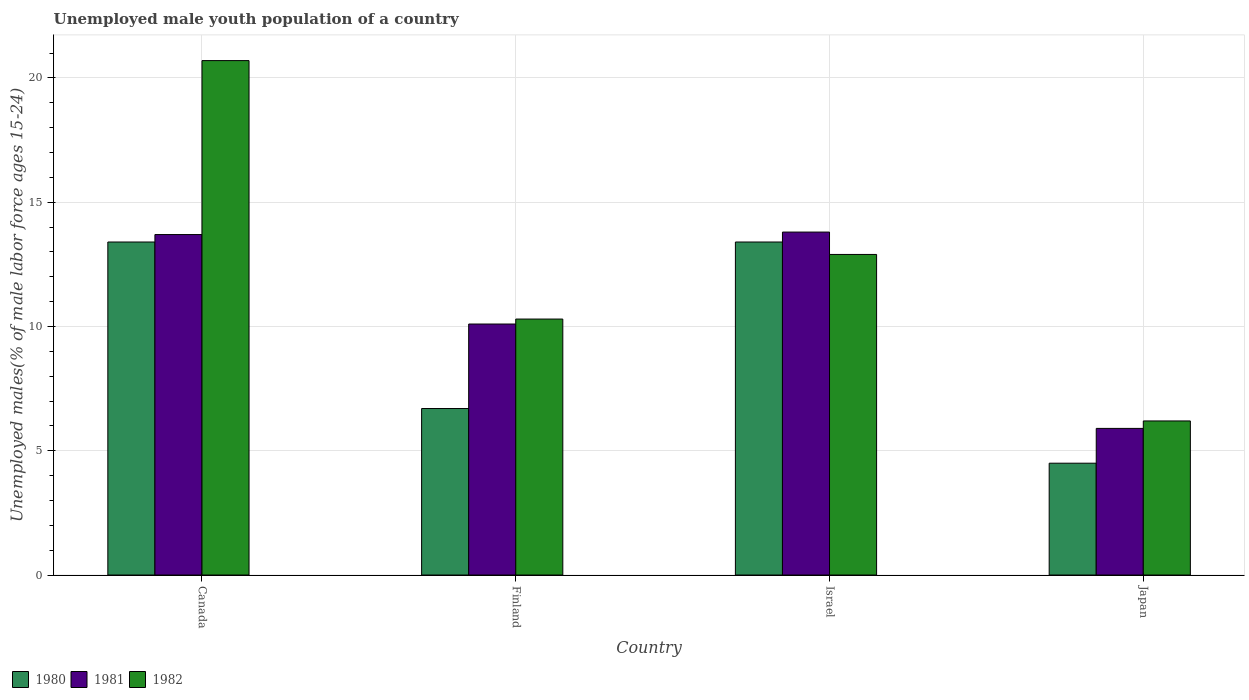How many groups of bars are there?
Provide a short and direct response. 4. Are the number of bars on each tick of the X-axis equal?
Provide a succinct answer. Yes. How many bars are there on the 2nd tick from the left?
Ensure brevity in your answer.  3. How many bars are there on the 2nd tick from the right?
Your answer should be compact. 3. What is the label of the 2nd group of bars from the left?
Provide a short and direct response. Finland. In how many cases, is the number of bars for a given country not equal to the number of legend labels?
Keep it short and to the point. 0. What is the percentage of unemployed male youth population in 1982 in Canada?
Your answer should be very brief. 20.7. Across all countries, what is the maximum percentage of unemployed male youth population in 1980?
Your response must be concise. 13.4. Across all countries, what is the minimum percentage of unemployed male youth population in 1981?
Offer a very short reply. 5.9. What is the total percentage of unemployed male youth population in 1982 in the graph?
Provide a succinct answer. 50.1. What is the difference between the percentage of unemployed male youth population in 1980 in Canada and that in Japan?
Give a very brief answer. 8.9. What is the difference between the percentage of unemployed male youth population in 1982 in Canada and the percentage of unemployed male youth population in 1980 in Japan?
Your answer should be very brief. 16.2. What is the average percentage of unemployed male youth population in 1980 per country?
Give a very brief answer. 9.5. What is the difference between the percentage of unemployed male youth population of/in 1981 and percentage of unemployed male youth population of/in 1982 in Canada?
Make the answer very short. -7. What is the ratio of the percentage of unemployed male youth population in 1981 in Finland to that in Israel?
Keep it short and to the point. 0.73. Is the difference between the percentage of unemployed male youth population in 1981 in Canada and Israel greater than the difference between the percentage of unemployed male youth population in 1982 in Canada and Israel?
Keep it short and to the point. No. What is the difference between the highest and the second highest percentage of unemployed male youth population in 1981?
Make the answer very short. 3.6. What is the difference between the highest and the lowest percentage of unemployed male youth population in 1982?
Your answer should be very brief. 14.5. In how many countries, is the percentage of unemployed male youth population in 1980 greater than the average percentage of unemployed male youth population in 1980 taken over all countries?
Your response must be concise. 2. Is the sum of the percentage of unemployed male youth population in 1982 in Canada and Finland greater than the maximum percentage of unemployed male youth population in 1980 across all countries?
Make the answer very short. Yes. What does the 1st bar from the right in Israel represents?
Provide a succinct answer. 1982. Does the graph contain grids?
Your answer should be compact. Yes. Where does the legend appear in the graph?
Your response must be concise. Bottom left. How are the legend labels stacked?
Provide a short and direct response. Horizontal. What is the title of the graph?
Provide a succinct answer. Unemployed male youth population of a country. What is the label or title of the X-axis?
Provide a short and direct response. Country. What is the label or title of the Y-axis?
Your answer should be very brief. Unemployed males(% of male labor force ages 15-24). What is the Unemployed males(% of male labor force ages 15-24) in 1980 in Canada?
Your answer should be compact. 13.4. What is the Unemployed males(% of male labor force ages 15-24) of 1981 in Canada?
Make the answer very short. 13.7. What is the Unemployed males(% of male labor force ages 15-24) in 1982 in Canada?
Provide a succinct answer. 20.7. What is the Unemployed males(% of male labor force ages 15-24) in 1980 in Finland?
Your answer should be compact. 6.7. What is the Unemployed males(% of male labor force ages 15-24) of 1981 in Finland?
Your answer should be compact. 10.1. What is the Unemployed males(% of male labor force ages 15-24) of 1982 in Finland?
Give a very brief answer. 10.3. What is the Unemployed males(% of male labor force ages 15-24) of 1980 in Israel?
Your answer should be compact. 13.4. What is the Unemployed males(% of male labor force ages 15-24) in 1981 in Israel?
Your response must be concise. 13.8. What is the Unemployed males(% of male labor force ages 15-24) of 1982 in Israel?
Your answer should be very brief. 12.9. What is the Unemployed males(% of male labor force ages 15-24) of 1980 in Japan?
Your answer should be compact. 4.5. What is the Unemployed males(% of male labor force ages 15-24) of 1981 in Japan?
Offer a very short reply. 5.9. What is the Unemployed males(% of male labor force ages 15-24) in 1982 in Japan?
Offer a terse response. 6.2. Across all countries, what is the maximum Unemployed males(% of male labor force ages 15-24) of 1980?
Offer a very short reply. 13.4. Across all countries, what is the maximum Unemployed males(% of male labor force ages 15-24) in 1981?
Give a very brief answer. 13.8. Across all countries, what is the maximum Unemployed males(% of male labor force ages 15-24) in 1982?
Keep it short and to the point. 20.7. Across all countries, what is the minimum Unemployed males(% of male labor force ages 15-24) of 1981?
Offer a terse response. 5.9. Across all countries, what is the minimum Unemployed males(% of male labor force ages 15-24) of 1982?
Your answer should be compact. 6.2. What is the total Unemployed males(% of male labor force ages 15-24) in 1981 in the graph?
Keep it short and to the point. 43.5. What is the total Unemployed males(% of male labor force ages 15-24) of 1982 in the graph?
Give a very brief answer. 50.1. What is the difference between the Unemployed males(% of male labor force ages 15-24) of 1980 in Canada and that in Finland?
Your answer should be compact. 6.7. What is the difference between the Unemployed males(% of male labor force ages 15-24) of 1981 in Canada and that in Finland?
Offer a very short reply. 3.6. What is the difference between the Unemployed males(% of male labor force ages 15-24) in 1982 in Canada and that in Israel?
Make the answer very short. 7.8. What is the difference between the Unemployed males(% of male labor force ages 15-24) in 1981 in Canada and that in Japan?
Your response must be concise. 7.8. What is the difference between the Unemployed males(% of male labor force ages 15-24) in 1980 in Finland and that in Israel?
Provide a succinct answer. -6.7. What is the difference between the Unemployed males(% of male labor force ages 15-24) of 1981 in Finland and that in Israel?
Provide a short and direct response. -3.7. What is the difference between the Unemployed males(% of male labor force ages 15-24) in 1981 in Israel and that in Japan?
Your answer should be compact. 7.9. What is the difference between the Unemployed males(% of male labor force ages 15-24) of 1980 in Canada and the Unemployed males(% of male labor force ages 15-24) of 1981 in Finland?
Give a very brief answer. 3.3. What is the difference between the Unemployed males(% of male labor force ages 15-24) in 1980 in Canada and the Unemployed males(% of male labor force ages 15-24) in 1982 in Finland?
Provide a succinct answer. 3.1. What is the difference between the Unemployed males(% of male labor force ages 15-24) of 1981 in Canada and the Unemployed males(% of male labor force ages 15-24) of 1982 in Finland?
Offer a terse response. 3.4. What is the difference between the Unemployed males(% of male labor force ages 15-24) of 1980 in Canada and the Unemployed males(% of male labor force ages 15-24) of 1981 in Israel?
Your response must be concise. -0.4. What is the difference between the Unemployed males(% of male labor force ages 15-24) in 1980 in Canada and the Unemployed males(% of male labor force ages 15-24) in 1982 in Israel?
Ensure brevity in your answer.  0.5. What is the difference between the Unemployed males(% of male labor force ages 15-24) in 1980 in Finland and the Unemployed males(% of male labor force ages 15-24) in 1981 in Israel?
Ensure brevity in your answer.  -7.1. What is the difference between the Unemployed males(% of male labor force ages 15-24) in 1980 in Finland and the Unemployed males(% of male labor force ages 15-24) in 1982 in Israel?
Your answer should be compact. -6.2. What is the difference between the Unemployed males(% of male labor force ages 15-24) in 1981 in Finland and the Unemployed males(% of male labor force ages 15-24) in 1982 in Israel?
Make the answer very short. -2.8. What is the difference between the Unemployed males(% of male labor force ages 15-24) in 1980 in Finland and the Unemployed males(% of male labor force ages 15-24) in 1982 in Japan?
Give a very brief answer. 0.5. What is the average Unemployed males(% of male labor force ages 15-24) in 1981 per country?
Your answer should be very brief. 10.88. What is the average Unemployed males(% of male labor force ages 15-24) in 1982 per country?
Offer a terse response. 12.53. What is the difference between the Unemployed males(% of male labor force ages 15-24) of 1980 and Unemployed males(% of male labor force ages 15-24) of 1982 in Canada?
Ensure brevity in your answer.  -7.3. What is the difference between the Unemployed males(% of male labor force ages 15-24) in 1981 and Unemployed males(% of male labor force ages 15-24) in 1982 in Canada?
Give a very brief answer. -7. What is the difference between the Unemployed males(% of male labor force ages 15-24) in 1980 and Unemployed males(% of male labor force ages 15-24) in 1981 in Finland?
Offer a very short reply. -3.4. What is the difference between the Unemployed males(% of male labor force ages 15-24) of 1980 and Unemployed males(% of male labor force ages 15-24) of 1982 in Finland?
Your response must be concise. -3.6. What is the difference between the Unemployed males(% of male labor force ages 15-24) of 1981 and Unemployed males(% of male labor force ages 15-24) of 1982 in Finland?
Offer a terse response. -0.2. What is the difference between the Unemployed males(% of male labor force ages 15-24) in 1980 and Unemployed males(% of male labor force ages 15-24) in 1981 in Israel?
Give a very brief answer. -0.4. What is the difference between the Unemployed males(% of male labor force ages 15-24) in 1980 and Unemployed males(% of male labor force ages 15-24) in 1982 in Israel?
Provide a short and direct response. 0.5. What is the difference between the Unemployed males(% of male labor force ages 15-24) in 1980 and Unemployed males(% of male labor force ages 15-24) in 1981 in Japan?
Provide a succinct answer. -1.4. What is the ratio of the Unemployed males(% of male labor force ages 15-24) of 1980 in Canada to that in Finland?
Provide a succinct answer. 2. What is the ratio of the Unemployed males(% of male labor force ages 15-24) of 1981 in Canada to that in Finland?
Keep it short and to the point. 1.36. What is the ratio of the Unemployed males(% of male labor force ages 15-24) of 1982 in Canada to that in Finland?
Provide a succinct answer. 2.01. What is the ratio of the Unemployed males(% of male labor force ages 15-24) in 1982 in Canada to that in Israel?
Provide a succinct answer. 1.6. What is the ratio of the Unemployed males(% of male labor force ages 15-24) of 1980 in Canada to that in Japan?
Provide a succinct answer. 2.98. What is the ratio of the Unemployed males(% of male labor force ages 15-24) in 1981 in Canada to that in Japan?
Offer a very short reply. 2.32. What is the ratio of the Unemployed males(% of male labor force ages 15-24) of 1982 in Canada to that in Japan?
Ensure brevity in your answer.  3.34. What is the ratio of the Unemployed males(% of male labor force ages 15-24) in 1980 in Finland to that in Israel?
Offer a very short reply. 0.5. What is the ratio of the Unemployed males(% of male labor force ages 15-24) in 1981 in Finland to that in Israel?
Offer a terse response. 0.73. What is the ratio of the Unemployed males(% of male labor force ages 15-24) of 1982 in Finland to that in Israel?
Provide a short and direct response. 0.8. What is the ratio of the Unemployed males(% of male labor force ages 15-24) of 1980 in Finland to that in Japan?
Ensure brevity in your answer.  1.49. What is the ratio of the Unemployed males(% of male labor force ages 15-24) in 1981 in Finland to that in Japan?
Your answer should be very brief. 1.71. What is the ratio of the Unemployed males(% of male labor force ages 15-24) in 1982 in Finland to that in Japan?
Make the answer very short. 1.66. What is the ratio of the Unemployed males(% of male labor force ages 15-24) of 1980 in Israel to that in Japan?
Your response must be concise. 2.98. What is the ratio of the Unemployed males(% of male labor force ages 15-24) of 1981 in Israel to that in Japan?
Offer a terse response. 2.34. What is the ratio of the Unemployed males(% of male labor force ages 15-24) of 1982 in Israel to that in Japan?
Your answer should be very brief. 2.08. What is the difference between the highest and the second highest Unemployed males(% of male labor force ages 15-24) of 1980?
Keep it short and to the point. 0. What is the difference between the highest and the lowest Unemployed males(% of male labor force ages 15-24) in 1980?
Keep it short and to the point. 8.9. What is the difference between the highest and the lowest Unemployed males(% of male labor force ages 15-24) of 1982?
Offer a very short reply. 14.5. 